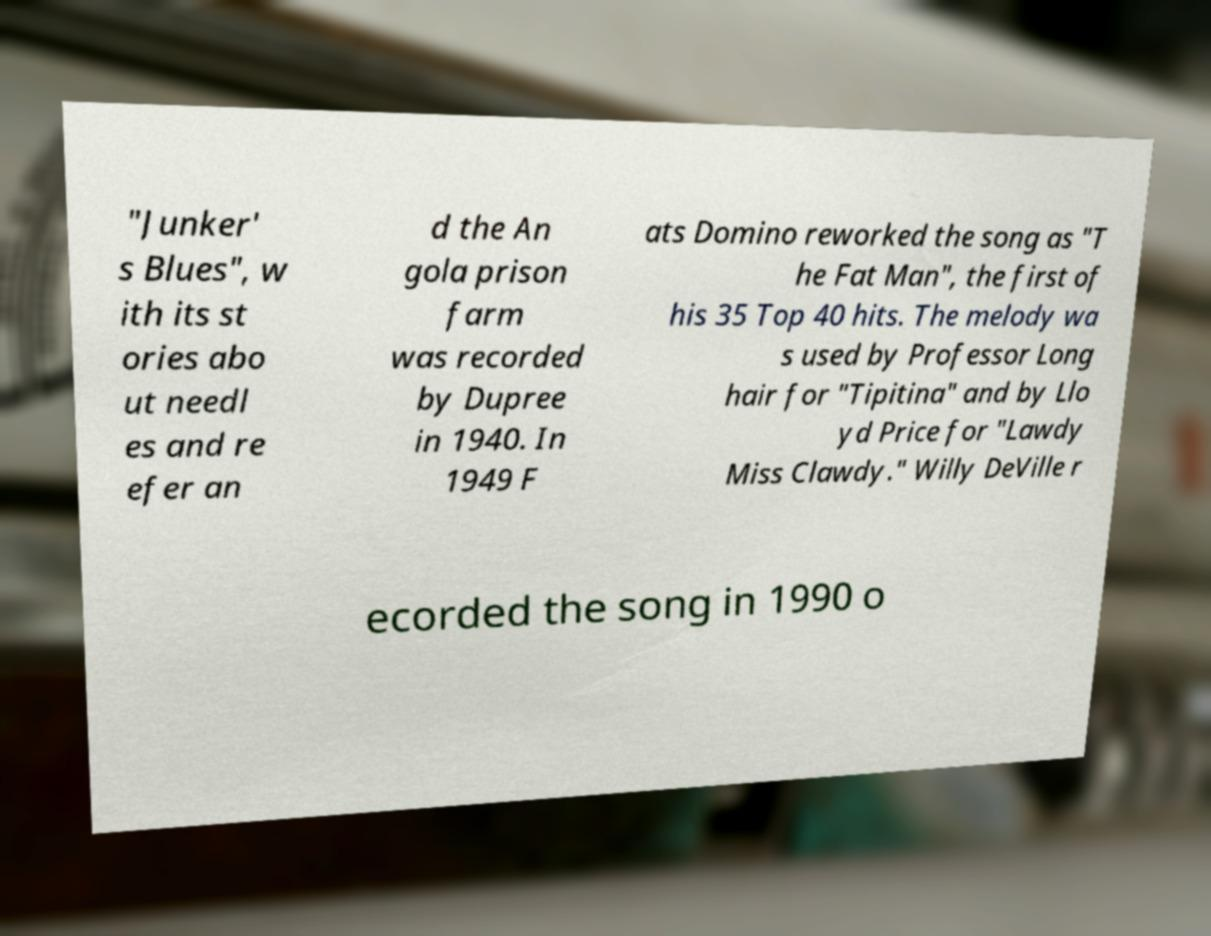Please identify and transcribe the text found in this image. "Junker' s Blues", w ith its st ories abo ut needl es and re efer an d the An gola prison farm was recorded by Dupree in 1940. In 1949 F ats Domino reworked the song as "T he Fat Man", the first of his 35 Top 40 hits. The melody wa s used by Professor Long hair for "Tipitina" and by Llo yd Price for "Lawdy Miss Clawdy." Willy DeVille r ecorded the song in 1990 o 